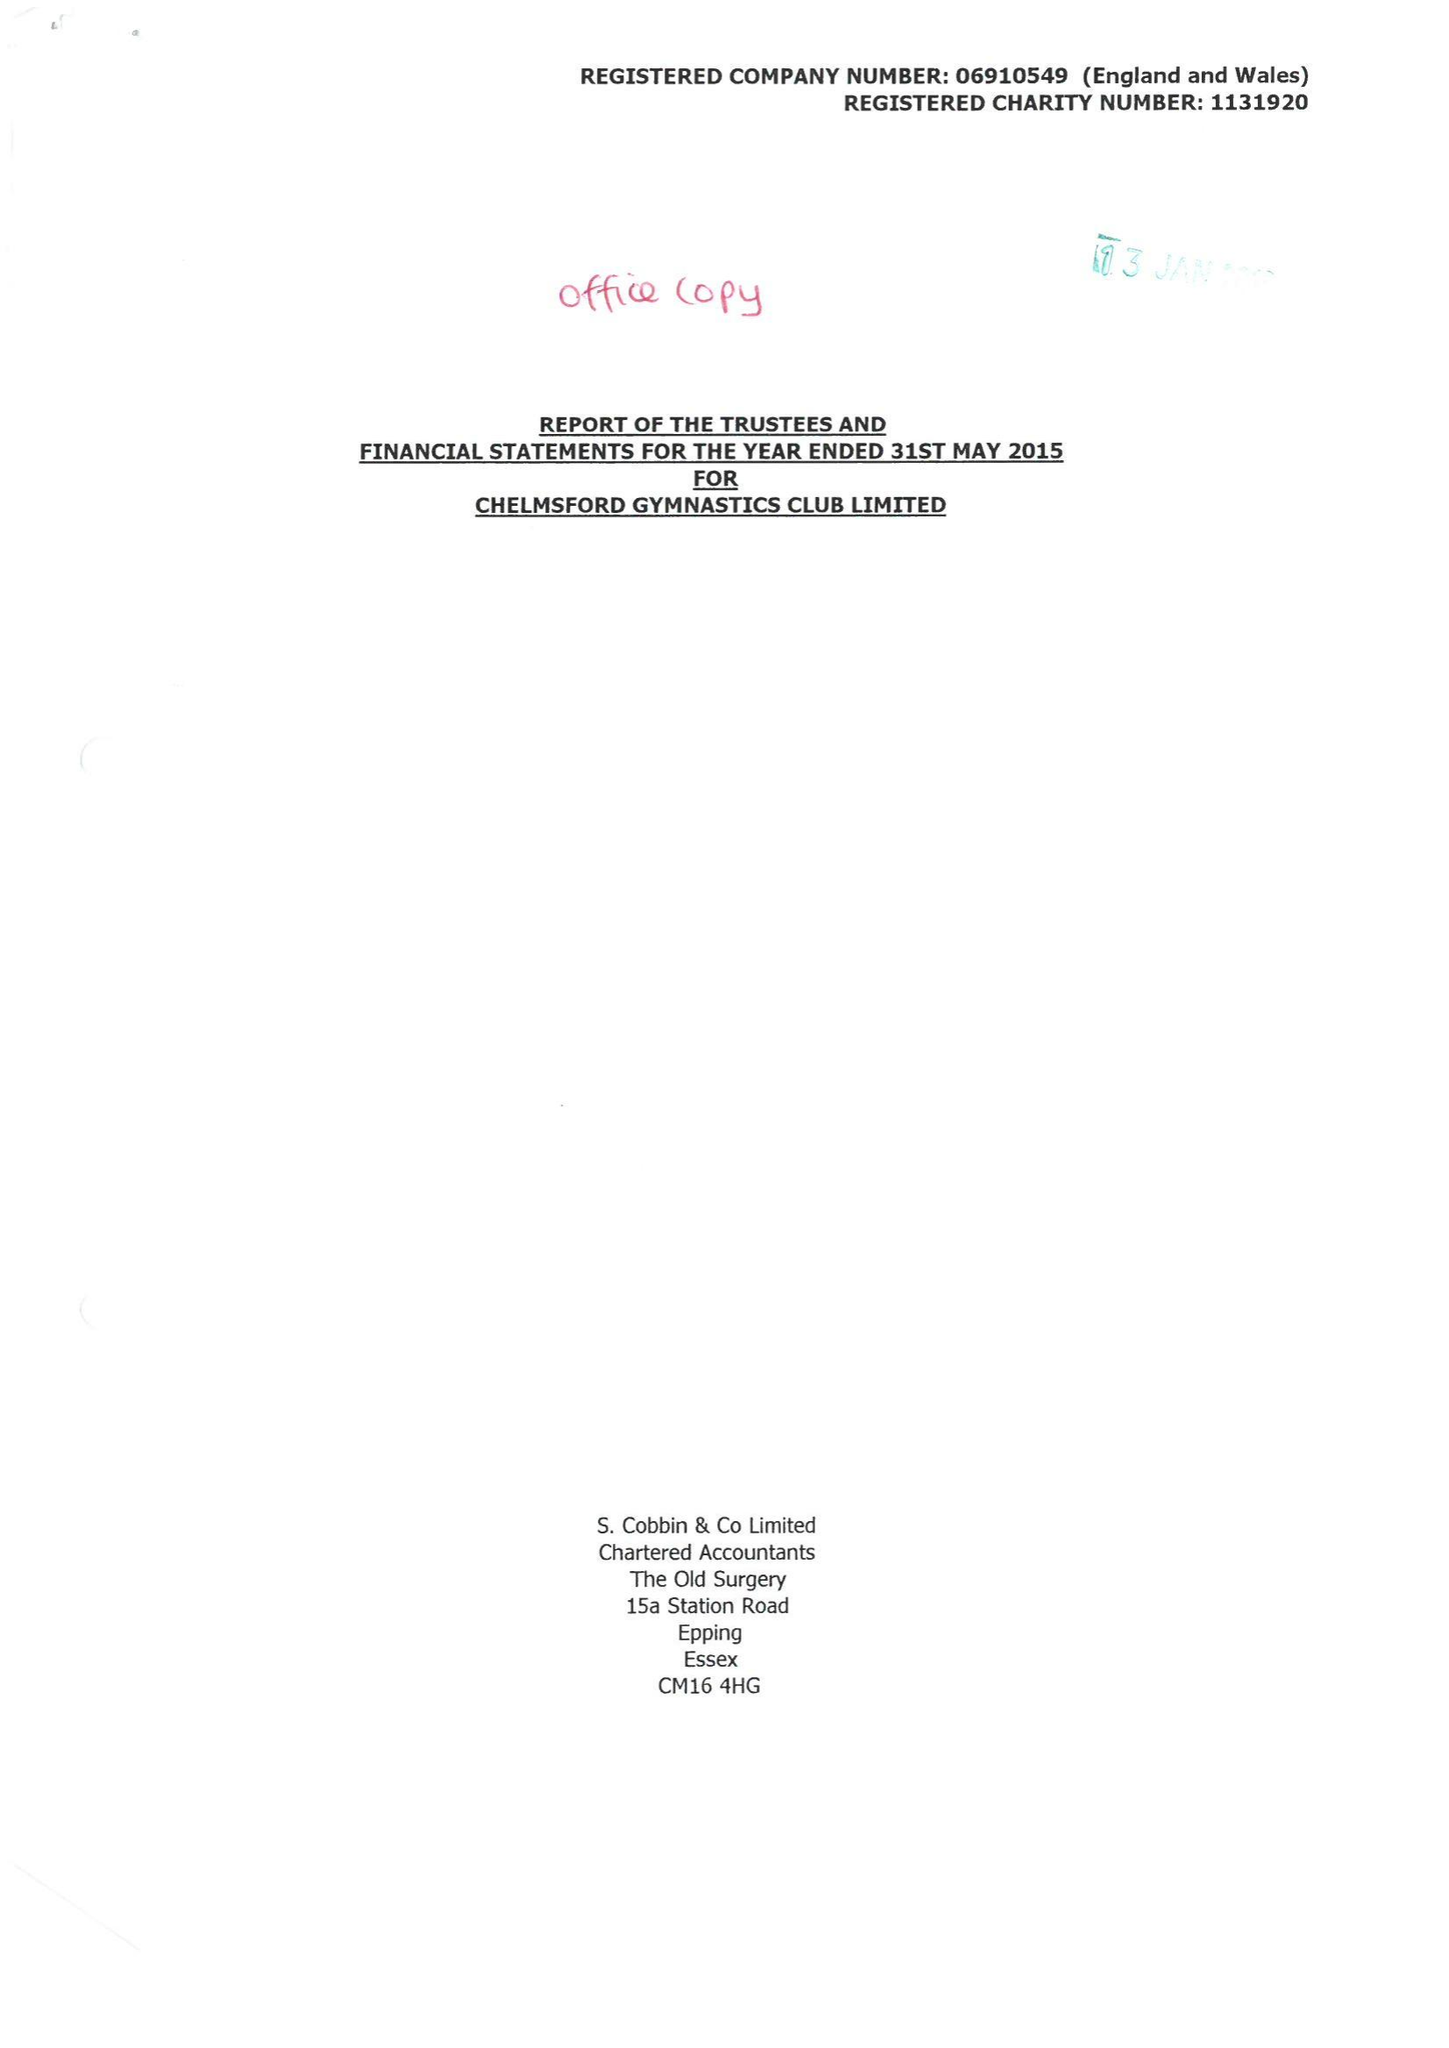What is the value for the address__post_town?
Answer the question using a single word or phrase. CHELMSFORD 